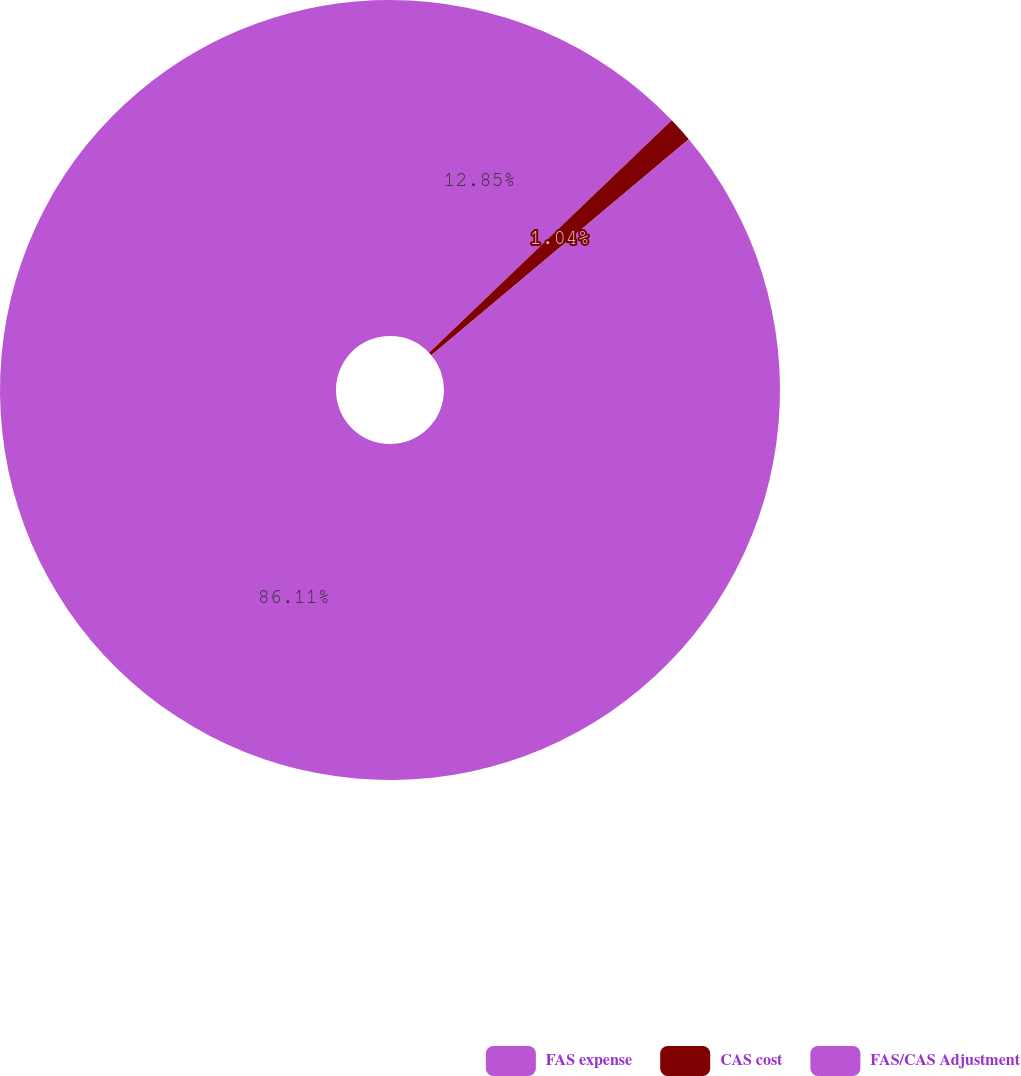Convert chart to OTSL. <chart><loc_0><loc_0><loc_500><loc_500><pie_chart><fcel>FAS expense<fcel>CAS cost<fcel>FAS/CAS Adjustment<nl><fcel>12.85%<fcel>1.04%<fcel>86.11%<nl></chart> 